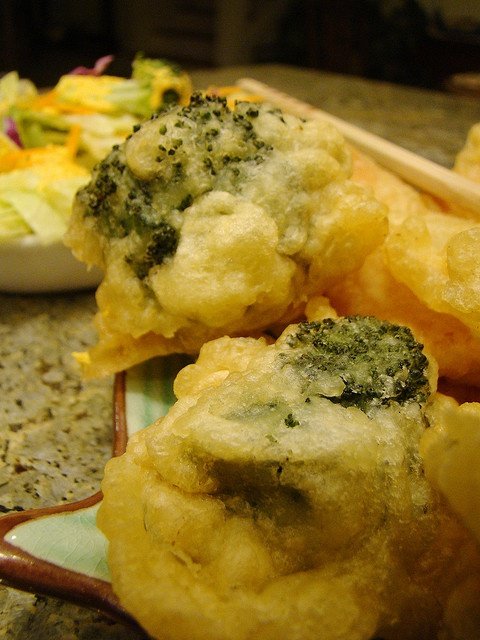Describe the objects in this image and their specific colors. I can see broccoli in black, olive, and tan tones, broccoli in black and olive tones, and bowl in black and olive tones in this image. 